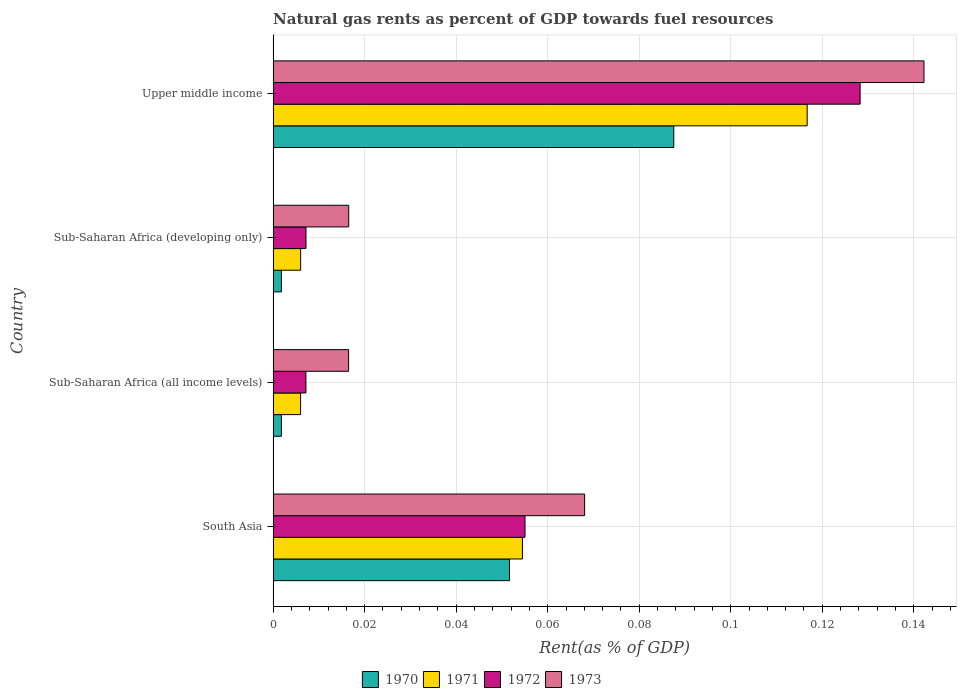How many groups of bars are there?
Give a very brief answer. 4. Are the number of bars on each tick of the Y-axis equal?
Provide a succinct answer. Yes. How many bars are there on the 1st tick from the top?
Your answer should be very brief. 4. What is the label of the 2nd group of bars from the top?
Offer a very short reply. Sub-Saharan Africa (developing only). What is the matural gas rent in 1970 in Upper middle income?
Your answer should be compact. 0.09. Across all countries, what is the maximum matural gas rent in 1970?
Give a very brief answer. 0.09. Across all countries, what is the minimum matural gas rent in 1970?
Your response must be concise. 0. In which country was the matural gas rent in 1973 maximum?
Provide a short and direct response. Upper middle income. In which country was the matural gas rent in 1972 minimum?
Your response must be concise. Sub-Saharan Africa (all income levels). What is the total matural gas rent in 1970 in the graph?
Give a very brief answer. 0.14. What is the difference between the matural gas rent in 1970 in Sub-Saharan Africa (all income levels) and that in Upper middle income?
Your response must be concise. -0.09. What is the difference between the matural gas rent in 1972 in Sub-Saharan Africa (all income levels) and the matural gas rent in 1973 in South Asia?
Your answer should be very brief. -0.06. What is the average matural gas rent in 1970 per country?
Offer a terse response. 0.04. What is the difference between the matural gas rent in 1971 and matural gas rent in 1970 in Upper middle income?
Your answer should be compact. 0.03. What is the ratio of the matural gas rent in 1970 in Sub-Saharan Africa (developing only) to that in Upper middle income?
Offer a very short reply. 0.02. Is the matural gas rent in 1971 in South Asia less than that in Sub-Saharan Africa (developing only)?
Provide a short and direct response. No. What is the difference between the highest and the second highest matural gas rent in 1973?
Your response must be concise. 0.07. What is the difference between the highest and the lowest matural gas rent in 1970?
Your answer should be compact. 0.09. Is it the case that in every country, the sum of the matural gas rent in 1973 and matural gas rent in 1971 is greater than the sum of matural gas rent in 1970 and matural gas rent in 1972?
Offer a terse response. No. What does the 3rd bar from the top in Sub-Saharan Africa (all income levels) represents?
Offer a terse response. 1971. Is it the case that in every country, the sum of the matural gas rent in 1972 and matural gas rent in 1973 is greater than the matural gas rent in 1971?
Offer a very short reply. Yes. Are all the bars in the graph horizontal?
Your answer should be compact. Yes. How many countries are there in the graph?
Make the answer very short. 4. What is the difference between two consecutive major ticks on the X-axis?
Make the answer very short. 0.02. Are the values on the major ticks of X-axis written in scientific E-notation?
Provide a short and direct response. No. Where does the legend appear in the graph?
Your response must be concise. Bottom center. What is the title of the graph?
Provide a short and direct response. Natural gas rents as percent of GDP towards fuel resources. What is the label or title of the X-axis?
Offer a terse response. Rent(as % of GDP). What is the Rent(as % of GDP) of 1970 in South Asia?
Make the answer very short. 0.05. What is the Rent(as % of GDP) of 1971 in South Asia?
Your answer should be compact. 0.05. What is the Rent(as % of GDP) of 1972 in South Asia?
Your answer should be very brief. 0.06. What is the Rent(as % of GDP) in 1973 in South Asia?
Your answer should be compact. 0.07. What is the Rent(as % of GDP) of 1970 in Sub-Saharan Africa (all income levels)?
Offer a very short reply. 0. What is the Rent(as % of GDP) of 1971 in Sub-Saharan Africa (all income levels)?
Provide a succinct answer. 0.01. What is the Rent(as % of GDP) in 1972 in Sub-Saharan Africa (all income levels)?
Offer a terse response. 0.01. What is the Rent(as % of GDP) in 1973 in Sub-Saharan Africa (all income levels)?
Provide a short and direct response. 0.02. What is the Rent(as % of GDP) of 1970 in Sub-Saharan Africa (developing only)?
Keep it short and to the point. 0. What is the Rent(as % of GDP) of 1971 in Sub-Saharan Africa (developing only)?
Your answer should be compact. 0.01. What is the Rent(as % of GDP) in 1972 in Sub-Saharan Africa (developing only)?
Your answer should be very brief. 0.01. What is the Rent(as % of GDP) in 1973 in Sub-Saharan Africa (developing only)?
Provide a short and direct response. 0.02. What is the Rent(as % of GDP) of 1970 in Upper middle income?
Your answer should be very brief. 0.09. What is the Rent(as % of GDP) of 1971 in Upper middle income?
Make the answer very short. 0.12. What is the Rent(as % of GDP) of 1972 in Upper middle income?
Provide a short and direct response. 0.13. What is the Rent(as % of GDP) of 1973 in Upper middle income?
Keep it short and to the point. 0.14. Across all countries, what is the maximum Rent(as % of GDP) in 1970?
Ensure brevity in your answer.  0.09. Across all countries, what is the maximum Rent(as % of GDP) in 1971?
Offer a very short reply. 0.12. Across all countries, what is the maximum Rent(as % of GDP) in 1972?
Offer a very short reply. 0.13. Across all countries, what is the maximum Rent(as % of GDP) in 1973?
Make the answer very short. 0.14. Across all countries, what is the minimum Rent(as % of GDP) of 1970?
Make the answer very short. 0. Across all countries, what is the minimum Rent(as % of GDP) of 1971?
Your response must be concise. 0.01. Across all countries, what is the minimum Rent(as % of GDP) of 1972?
Your answer should be compact. 0.01. Across all countries, what is the minimum Rent(as % of GDP) in 1973?
Your response must be concise. 0.02. What is the total Rent(as % of GDP) in 1970 in the graph?
Give a very brief answer. 0.14. What is the total Rent(as % of GDP) of 1971 in the graph?
Offer a terse response. 0.18. What is the total Rent(as % of GDP) of 1972 in the graph?
Your answer should be compact. 0.2. What is the total Rent(as % of GDP) of 1973 in the graph?
Your answer should be very brief. 0.24. What is the difference between the Rent(as % of GDP) in 1970 in South Asia and that in Sub-Saharan Africa (all income levels)?
Your response must be concise. 0.05. What is the difference between the Rent(as % of GDP) of 1971 in South Asia and that in Sub-Saharan Africa (all income levels)?
Your answer should be very brief. 0.05. What is the difference between the Rent(as % of GDP) in 1972 in South Asia and that in Sub-Saharan Africa (all income levels)?
Your answer should be compact. 0.05. What is the difference between the Rent(as % of GDP) of 1973 in South Asia and that in Sub-Saharan Africa (all income levels)?
Provide a succinct answer. 0.05. What is the difference between the Rent(as % of GDP) of 1970 in South Asia and that in Sub-Saharan Africa (developing only)?
Offer a terse response. 0.05. What is the difference between the Rent(as % of GDP) of 1971 in South Asia and that in Sub-Saharan Africa (developing only)?
Provide a short and direct response. 0.05. What is the difference between the Rent(as % of GDP) in 1972 in South Asia and that in Sub-Saharan Africa (developing only)?
Offer a terse response. 0.05. What is the difference between the Rent(as % of GDP) of 1973 in South Asia and that in Sub-Saharan Africa (developing only)?
Your answer should be compact. 0.05. What is the difference between the Rent(as % of GDP) in 1970 in South Asia and that in Upper middle income?
Give a very brief answer. -0.04. What is the difference between the Rent(as % of GDP) in 1971 in South Asia and that in Upper middle income?
Make the answer very short. -0.06. What is the difference between the Rent(as % of GDP) of 1972 in South Asia and that in Upper middle income?
Keep it short and to the point. -0.07. What is the difference between the Rent(as % of GDP) of 1973 in South Asia and that in Upper middle income?
Provide a succinct answer. -0.07. What is the difference between the Rent(as % of GDP) in 1970 in Sub-Saharan Africa (all income levels) and that in Sub-Saharan Africa (developing only)?
Provide a succinct answer. -0. What is the difference between the Rent(as % of GDP) in 1971 in Sub-Saharan Africa (all income levels) and that in Sub-Saharan Africa (developing only)?
Give a very brief answer. -0. What is the difference between the Rent(as % of GDP) in 1972 in Sub-Saharan Africa (all income levels) and that in Sub-Saharan Africa (developing only)?
Ensure brevity in your answer.  -0. What is the difference between the Rent(as % of GDP) in 1973 in Sub-Saharan Africa (all income levels) and that in Sub-Saharan Africa (developing only)?
Keep it short and to the point. -0. What is the difference between the Rent(as % of GDP) in 1970 in Sub-Saharan Africa (all income levels) and that in Upper middle income?
Offer a very short reply. -0.09. What is the difference between the Rent(as % of GDP) in 1971 in Sub-Saharan Africa (all income levels) and that in Upper middle income?
Ensure brevity in your answer.  -0.11. What is the difference between the Rent(as % of GDP) of 1972 in Sub-Saharan Africa (all income levels) and that in Upper middle income?
Provide a short and direct response. -0.12. What is the difference between the Rent(as % of GDP) in 1973 in Sub-Saharan Africa (all income levels) and that in Upper middle income?
Provide a succinct answer. -0.13. What is the difference between the Rent(as % of GDP) in 1970 in Sub-Saharan Africa (developing only) and that in Upper middle income?
Offer a very short reply. -0.09. What is the difference between the Rent(as % of GDP) in 1971 in Sub-Saharan Africa (developing only) and that in Upper middle income?
Offer a terse response. -0.11. What is the difference between the Rent(as % of GDP) in 1972 in Sub-Saharan Africa (developing only) and that in Upper middle income?
Your answer should be very brief. -0.12. What is the difference between the Rent(as % of GDP) in 1973 in Sub-Saharan Africa (developing only) and that in Upper middle income?
Give a very brief answer. -0.13. What is the difference between the Rent(as % of GDP) in 1970 in South Asia and the Rent(as % of GDP) in 1971 in Sub-Saharan Africa (all income levels)?
Provide a succinct answer. 0.05. What is the difference between the Rent(as % of GDP) of 1970 in South Asia and the Rent(as % of GDP) of 1972 in Sub-Saharan Africa (all income levels)?
Your answer should be compact. 0.04. What is the difference between the Rent(as % of GDP) in 1970 in South Asia and the Rent(as % of GDP) in 1973 in Sub-Saharan Africa (all income levels)?
Keep it short and to the point. 0.04. What is the difference between the Rent(as % of GDP) in 1971 in South Asia and the Rent(as % of GDP) in 1972 in Sub-Saharan Africa (all income levels)?
Keep it short and to the point. 0.05. What is the difference between the Rent(as % of GDP) of 1971 in South Asia and the Rent(as % of GDP) of 1973 in Sub-Saharan Africa (all income levels)?
Ensure brevity in your answer.  0.04. What is the difference between the Rent(as % of GDP) of 1972 in South Asia and the Rent(as % of GDP) of 1973 in Sub-Saharan Africa (all income levels)?
Your answer should be compact. 0.04. What is the difference between the Rent(as % of GDP) of 1970 in South Asia and the Rent(as % of GDP) of 1971 in Sub-Saharan Africa (developing only)?
Your response must be concise. 0.05. What is the difference between the Rent(as % of GDP) of 1970 in South Asia and the Rent(as % of GDP) of 1972 in Sub-Saharan Africa (developing only)?
Provide a short and direct response. 0.04. What is the difference between the Rent(as % of GDP) of 1970 in South Asia and the Rent(as % of GDP) of 1973 in Sub-Saharan Africa (developing only)?
Ensure brevity in your answer.  0.04. What is the difference between the Rent(as % of GDP) of 1971 in South Asia and the Rent(as % of GDP) of 1972 in Sub-Saharan Africa (developing only)?
Provide a short and direct response. 0.05. What is the difference between the Rent(as % of GDP) of 1971 in South Asia and the Rent(as % of GDP) of 1973 in Sub-Saharan Africa (developing only)?
Your answer should be very brief. 0.04. What is the difference between the Rent(as % of GDP) of 1972 in South Asia and the Rent(as % of GDP) of 1973 in Sub-Saharan Africa (developing only)?
Your answer should be compact. 0.04. What is the difference between the Rent(as % of GDP) in 1970 in South Asia and the Rent(as % of GDP) in 1971 in Upper middle income?
Your answer should be compact. -0.07. What is the difference between the Rent(as % of GDP) of 1970 in South Asia and the Rent(as % of GDP) of 1972 in Upper middle income?
Make the answer very short. -0.08. What is the difference between the Rent(as % of GDP) of 1970 in South Asia and the Rent(as % of GDP) of 1973 in Upper middle income?
Give a very brief answer. -0.09. What is the difference between the Rent(as % of GDP) in 1971 in South Asia and the Rent(as % of GDP) in 1972 in Upper middle income?
Provide a short and direct response. -0.07. What is the difference between the Rent(as % of GDP) in 1971 in South Asia and the Rent(as % of GDP) in 1973 in Upper middle income?
Your answer should be very brief. -0.09. What is the difference between the Rent(as % of GDP) in 1972 in South Asia and the Rent(as % of GDP) in 1973 in Upper middle income?
Ensure brevity in your answer.  -0.09. What is the difference between the Rent(as % of GDP) of 1970 in Sub-Saharan Africa (all income levels) and the Rent(as % of GDP) of 1971 in Sub-Saharan Africa (developing only)?
Make the answer very short. -0. What is the difference between the Rent(as % of GDP) in 1970 in Sub-Saharan Africa (all income levels) and the Rent(as % of GDP) in 1972 in Sub-Saharan Africa (developing only)?
Your answer should be very brief. -0.01. What is the difference between the Rent(as % of GDP) in 1970 in Sub-Saharan Africa (all income levels) and the Rent(as % of GDP) in 1973 in Sub-Saharan Africa (developing only)?
Offer a terse response. -0.01. What is the difference between the Rent(as % of GDP) of 1971 in Sub-Saharan Africa (all income levels) and the Rent(as % of GDP) of 1972 in Sub-Saharan Africa (developing only)?
Keep it short and to the point. -0. What is the difference between the Rent(as % of GDP) of 1971 in Sub-Saharan Africa (all income levels) and the Rent(as % of GDP) of 1973 in Sub-Saharan Africa (developing only)?
Give a very brief answer. -0.01. What is the difference between the Rent(as % of GDP) of 1972 in Sub-Saharan Africa (all income levels) and the Rent(as % of GDP) of 1973 in Sub-Saharan Africa (developing only)?
Offer a very short reply. -0.01. What is the difference between the Rent(as % of GDP) in 1970 in Sub-Saharan Africa (all income levels) and the Rent(as % of GDP) in 1971 in Upper middle income?
Offer a terse response. -0.11. What is the difference between the Rent(as % of GDP) in 1970 in Sub-Saharan Africa (all income levels) and the Rent(as % of GDP) in 1972 in Upper middle income?
Give a very brief answer. -0.13. What is the difference between the Rent(as % of GDP) of 1970 in Sub-Saharan Africa (all income levels) and the Rent(as % of GDP) of 1973 in Upper middle income?
Provide a short and direct response. -0.14. What is the difference between the Rent(as % of GDP) in 1971 in Sub-Saharan Africa (all income levels) and the Rent(as % of GDP) in 1972 in Upper middle income?
Provide a succinct answer. -0.12. What is the difference between the Rent(as % of GDP) in 1971 in Sub-Saharan Africa (all income levels) and the Rent(as % of GDP) in 1973 in Upper middle income?
Ensure brevity in your answer.  -0.14. What is the difference between the Rent(as % of GDP) in 1972 in Sub-Saharan Africa (all income levels) and the Rent(as % of GDP) in 1973 in Upper middle income?
Offer a terse response. -0.14. What is the difference between the Rent(as % of GDP) in 1970 in Sub-Saharan Africa (developing only) and the Rent(as % of GDP) in 1971 in Upper middle income?
Your answer should be compact. -0.11. What is the difference between the Rent(as % of GDP) of 1970 in Sub-Saharan Africa (developing only) and the Rent(as % of GDP) of 1972 in Upper middle income?
Your answer should be compact. -0.13. What is the difference between the Rent(as % of GDP) in 1970 in Sub-Saharan Africa (developing only) and the Rent(as % of GDP) in 1973 in Upper middle income?
Provide a short and direct response. -0.14. What is the difference between the Rent(as % of GDP) of 1971 in Sub-Saharan Africa (developing only) and the Rent(as % of GDP) of 1972 in Upper middle income?
Give a very brief answer. -0.12. What is the difference between the Rent(as % of GDP) of 1971 in Sub-Saharan Africa (developing only) and the Rent(as % of GDP) of 1973 in Upper middle income?
Give a very brief answer. -0.14. What is the difference between the Rent(as % of GDP) in 1972 in Sub-Saharan Africa (developing only) and the Rent(as % of GDP) in 1973 in Upper middle income?
Offer a terse response. -0.14. What is the average Rent(as % of GDP) in 1970 per country?
Keep it short and to the point. 0.04. What is the average Rent(as % of GDP) of 1971 per country?
Your response must be concise. 0.05. What is the average Rent(as % of GDP) of 1972 per country?
Your response must be concise. 0.05. What is the average Rent(as % of GDP) in 1973 per country?
Provide a succinct answer. 0.06. What is the difference between the Rent(as % of GDP) in 1970 and Rent(as % of GDP) in 1971 in South Asia?
Your answer should be compact. -0. What is the difference between the Rent(as % of GDP) in 1970 and Rent(as % of GDP) in 1972 in South Asia?
Offer a terse response. -0. What is the difference between the Rent(as % of GDP) in 1970 and Rent(as % of GDP) in 1973 in South Asia?
Offer a very short reply. -0.02. What is the difference between the Rent(as % of GDP) in 1971 and Rent(as % of GDP) in 1972 in South Asia?
Your answer should be compact. -0. What is the difference between the Rent(as % of GDP) of 1971 and Rent(as % of GDP) of 1973 in South Asia?
Provide a succinct answer. -0.01. What is the difference between the Rent(as % of GDP) of 1972 and Rent(as % of GDP) of 1973 in South Asia?
Make the answer very short. -0.01. What is the difference between the Rent(as % of GDP) in 1970 and Rent(as % of GDP) in 1971 in Sub-Saharan Africa (all income levels)?
Give a very brief answer. -0. What is the difference between the Rent(as % of GDP) of 1970 and Rent(as % of GDP) of 1972 in Sub-Saharan Africa (all income levels)?
Ensure brevity in your answer.  -0.01. What is the difference between the Rent(as % of GDP) of 1970 and Rent(as % of GDP) of 1973 in Sub-Saharan Africa (all income levels)?
Make the answer very short. -0.01. What is the difference between the Rent(as % of GDP) of 1971 and Rent(as % of GDP) of 1972 in Sub-Saharan Africa (all income levels)?
Your response must be concise. -0. What is the difference between the Rent(as % of GDP) of 1971 and Rent(as % of GDP) of 1973 in Sub-Saharan Africa (all income levels)?
Your response must be concise. -0.01. What is the difference between the Rent(as % of GDP) of 1972 and Rent(as % of GDP) of 1973 in Sub-Saharan Africa (all income levels)?
Your response must be concise. -0.01. What is the difference between the Rent(as % of GDP) of 1970 and Rent(as % of GDP) of 1971 in Sub-Saharan Africa (developing only)?
Make the answer very short. -0. What is the difference between the Rent(as % of GDP) of 1970 and Rent(as % of GDP) of 1972 in Sub-Saharan Africa (developing only)?
Provide a succinct answer. -0.01. What is the difference between the Rent(as % of GDP) of 1970 and Rent(as % of GDP) of 1973 in Sub-Saharan Africa (developing only)?
Your response must be concise. -0.01. What is the difference between the Rent(as % of GDP) in 1971 and Rent(as % of GDP) in 1972 in Sub-Saharan Africa (developing only)?
Your answer should be compact. -0. What is the difference between the Rent(as % of GDP) of 1971 and Rent(as % of GDP) of 1973 in Sub-Saharan Africa (developing only)?
Make the answer very short. -0.01. What is the difference between the Rent(as % of GDP) in 1972 and Rent(as % of GDP) in 1973 in Sub-Saharan Africa (developing only)?
Offer a very short reply. -0.01. What is the difference between the Rent(as % of GDP) of 1970 and Rent(as % of GDP) of 1971 in Upper middle income?
Provide a succinct answer. -0.03. What is the difference between the Rent(as % of GDP) in 1970 and Rent(as % of GDP) in 1972 in Upper middle income?
Keep it short and to the point. -0.04. What is the difference between the Rent(as % of GDP) in 1970 and Rent(as % of GDP) in 1973 in Upper middle income?
Your response must be concise. -0.05. What is the difference between the Rent(as % of GDP) in 1971 and Rent(as % of GDP) in 1972 in Upper middle income?
Ensure brevity in your answer.  -0.01. What is the difference between the Rent(as % of GDP) in 1971 and Rent(as % of GDP) in 1973 in Upper middle income?
Make the answer very short. -0.03. What is the difference between the Rent(as % of GDP) in 1972 and Rent(as % of GDP) in 1973 in Upper middle income?
Give a very brief answer. -0.01. What is the ratio of the Rent(as % of GDP) in 1970 in South Asia to that in Sub-Saharan Africa (all income levels)?
Keep it short and to the point. 28.57. What is the ratio of the Rent(as % of GDP) of 1971 in South Asia to that in Sub-Saharan Africa (all income levels)?
Your answer should be very brief. 9.07. What is the ratio of the Rent(as % of GDP) in 1972 in South Asia to that in Sub-Saharan Africa (all income levels)?
Provide a succinct answer. 7.67. What is the ratio of the Rent(as % of GDP) of 1973 in South Asia to that in Sub-Saharan Africa (all income levels)?
Offer a terse response. 4.13. What is the ratio of the Rent(as % of GDP) in 1970 in South Asia to that in Sub-Saharan Africa (developing only)?
Offer a terse response. 28.53. What is the ratio of the Rent(as % of GDP) of 1971 in South Asia to that in Sub-Saharan Africa (developing only)?
Ensure brevity in your answer.  9.06. What is the ratio of the Rent(as % of GDP) of 1972 in South Asia to that in Sub-Saharan Africa (developing only)?
Give a very brief answer. 7.66. What is the ratio of the Rent(as % of GDP) in 1973 in South Asia to that in Sub-Saharan Africa (developing only)?
Your response must be concise. 4.12. What is the ratio of the Rent(as % of GDP) of 1970 in South Asia to that in Upper middle income?
Provide a short and direct response. 0.59. What is the ratio of the Rent(as % of GDP) in 1971 in South Asia to that in Upper middle income?
Ensure brevity in your answer.  0.47. What is the ratio of the Rent(as % of GDP) in 1972 in South Asia to that in Upper middle income?
Offer a very short reply. 0.43. What is the ratio of the Rent(as % of GDP) of 1973 in South Asia to that in Upper middle income?
Ensure brevity in your answer.  0.48. What is the ratio of the Rent(as % of GDP) in 1971 in Sub-Saharan Africa (all income levels) to that in Sub-Saharan Africa (developing only)?
Your response must be concise. 1. What is the ratio of the Rent(as % of GDP) of 1972 in Sub-Saharan Africa (all income levels) to that in Sub-Saharan Africa (developing only)?
Your answer should be compact. 1. What is the ratio of the Rent(as % of GDP) of 1970 in Sub-Saharan Africa (all income levels) to that in Upper middle income?
Your answer should be very brief. 0.02. What is the ratio of the Rent(as % of GDP) of 1971 in Sub-Saharan Africa (all income levels) to that in Upper middle income?
Your answer should be very brief. 0.05. What is the ratio of the Rent(as % of GDP) of 1972 in Sub-Saharan Africa (all income levels) to that in Upper middle income?
Keep it short and to the point. 0.06. What is the ratio of the Rent(as % of GDP) in 1973 in Sub-Saharan Africa (all income levels) to that in Upper middle income?
Make the answer very short. 0.12. What is the ratio of the Rent(as % of GDP) of 1970 in Sub-Saharan Africa (developing only) to that in Upper middle income?
Your answer should be very brief. 0.02. What is the ratio of the Rent(as % of GDP) in 1971 in Sub-Saharan Africa (developing only) to that in Upper middle income?
Your response must be concise. 0.05. What is the ratio of the Rent(as % of GDP) of 1972 in Sub-Saharan Africa (developing only) to that in Upper middle income?
Offer a very short reply. 0.06. What is the ratio of the Rent(as % of GDP) of 1973 in Sub-Saharan Africa (developing only) to that in Upper middle income?
Offer a terse response. 0.12. What is the difference between the highest and the second highest Rent(as % of GDP) of 1970?
Ensure brevity in your answer.  0.04. What is the difference between the highest and the second highest Rent(as % of GDP) of 1971?
Your response must be concise. 0.06. What is the difference between the highest and the second highest Rent(as % of GDP) in 1972?
Provide a succinct answer. 0.07. What is the difference between the highest and the second highest Rent(as % of GDP) of 1973?
Keep it short and to the point. 0.07. What is the difference between the highest and the lowest Rent(as % of GDP) in 1970?
Keep it short and to the point. 0.09. What is the difference between the highest and the lowest Rent(as % of GDP) of 1971?
Keep it short and to the point. 0.11. What is the difference between the highest and the lowest Rent(as % of GDP) in 1972?
Offer a terse response. 0.12. What is the difference between the highest and the lowest Rent(as % of GDP) in 1973?
Provide a short and direct response. 0.13. 